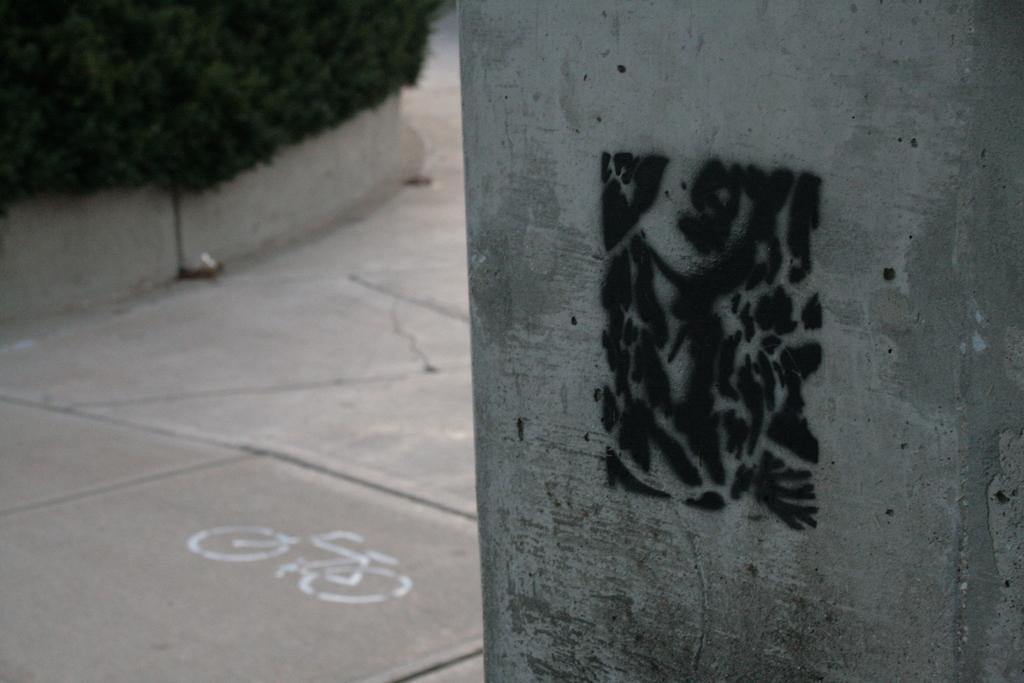Please provide a concise description of this image. On the right side of the image, we can see a pillar with painting. On the left side of the image, we can see the walkway, plants and bicycle figure on the path. 